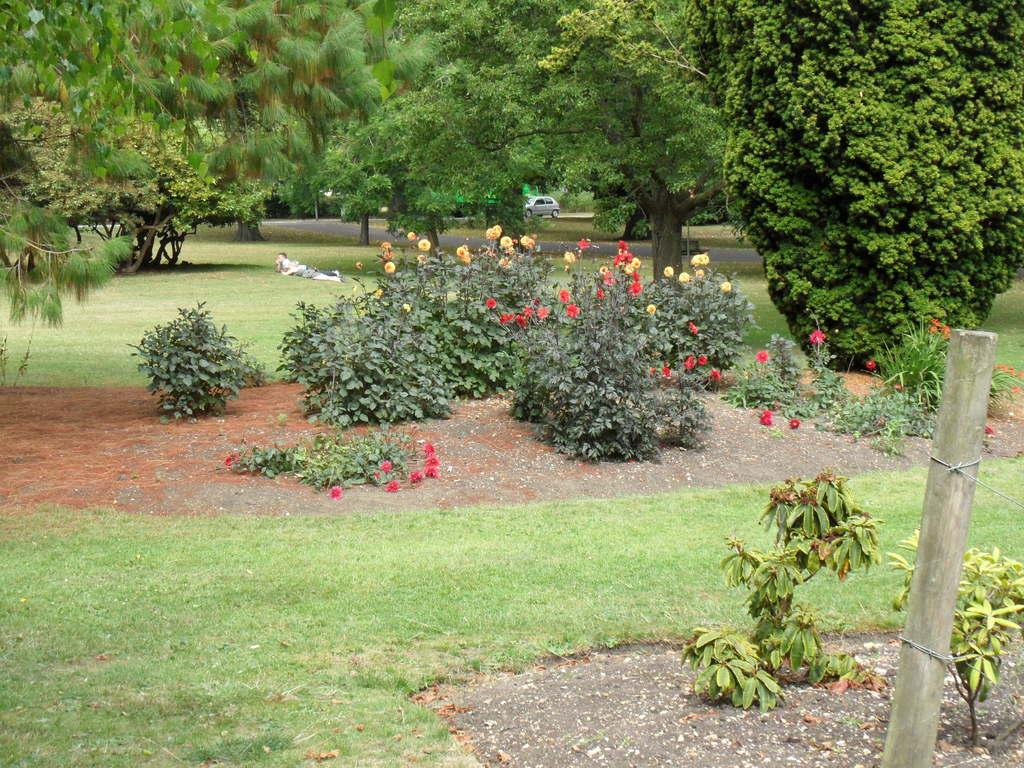What type of vegetation can be seen in the image? There are plants, grass, and trees in the image. What is the ground surface like in the image? The ground is covered with grass in the image. What can be seen in the background of the image? A car is visible in the background of the image. What object is located on the right side of the image? There is a wooden stick on the right side of the image. What type of lunch is being prepared in the image? There is no indication of any lunch preparation in the image. Is there an umbrella present in the image? No, there is no umbrella present in the image. 